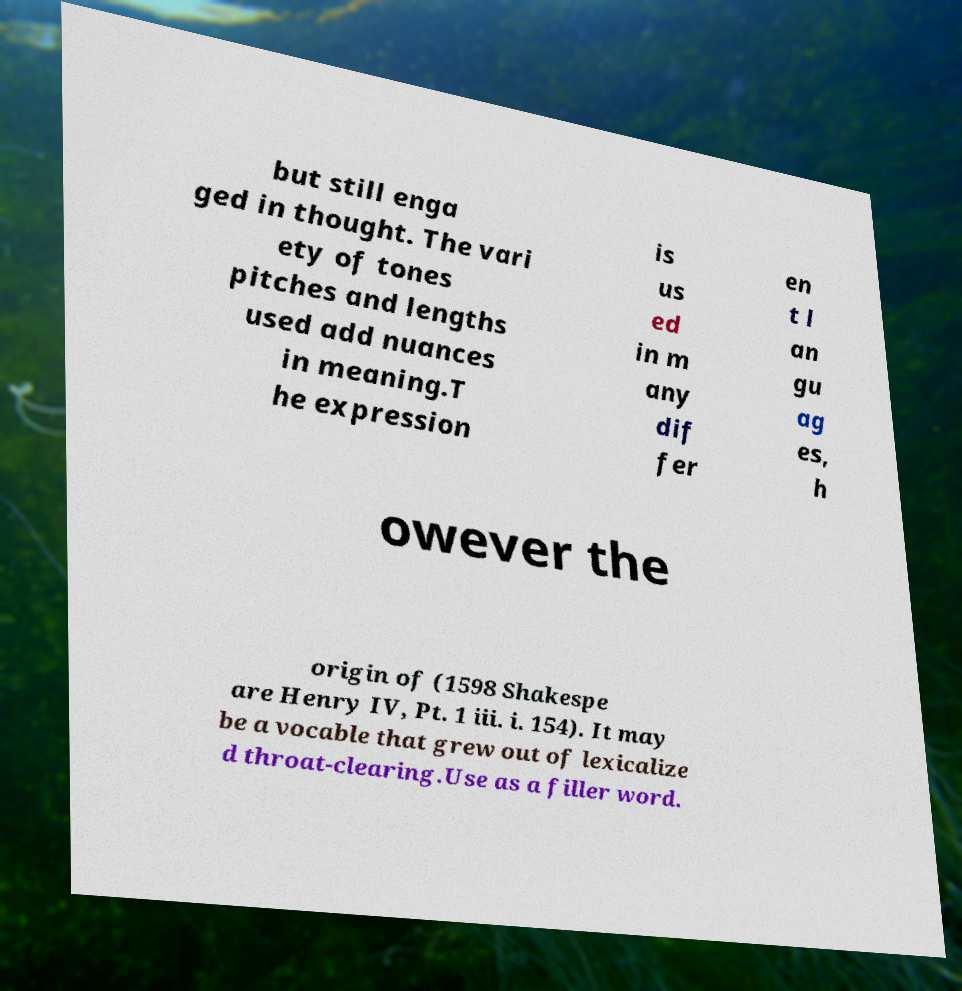What messages or text are displayed in this image? I need them in a readable, typed format. but still enga ged in thought. The vari ety of tones pitches and lengths used add nuances in meaning.T he expression is us ed in m any dif fer en t l an gu ag es, h owever the origin of (1598 Shakespe are Henry IV, Pt. 1 iii. i. 154). It may be a vocable that grew out of lexicalize d throat-clearing.Use as a filler word. 